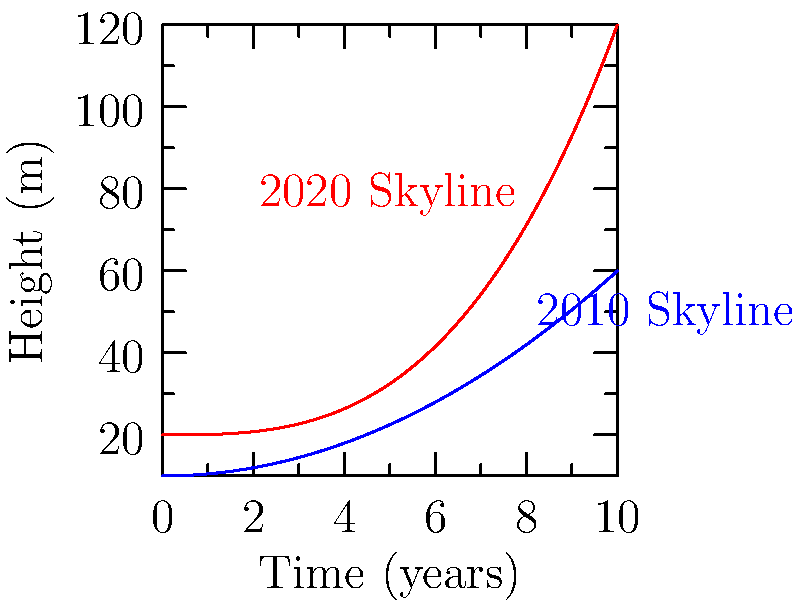As an immigrant painter capturing Sydney's changing landscapes, you've observed the city's skyline evolve over the past decade. The graph shows simplified representations of Sydney's skyline in 2010 and 2020, where the height (in meters) is a function of time (in years). The 2010 skyline is represented by $f(x) = 10 + 0.5x^2$, and the 2020 skyline by $g(x) = 20 + 0.1x^3$, where $x$ is the time in years.

Calculate the difference in the rate of change of the skyline heights at the 5-year mark (x = 5) between 2020 and 2010. Express your answer in meters per year. To solve this problem, we need to follow these steps:

1) First, we need to find the derivatives of both functions to get the rate of change:
   $f'(x) = \frac{d}{dx}(10 + 0.5x^2) = x$
   $g'(x) = \frac{d}{dx}(20 + 0.1x^3) = 0.3x^2$

2) Now, we need to evaluate these derivatives at x = 5:
   $f'(5) = 5$ m/year
   $g'(5) = 0.3(5^2) = 0.3(25) = 7.5$ m/year

3) The question asks for the difference in the rate of change between 2020 and 2010:
   Difference = $g'(5) - f'(5) = 7.5 - 5 = 2.5$ m/year

Therefore, at the 5-year mark, the 2020 skyline is changing 2.5 meters per year faster than the 2010 skyline.
Answer: 2.5 m/year 